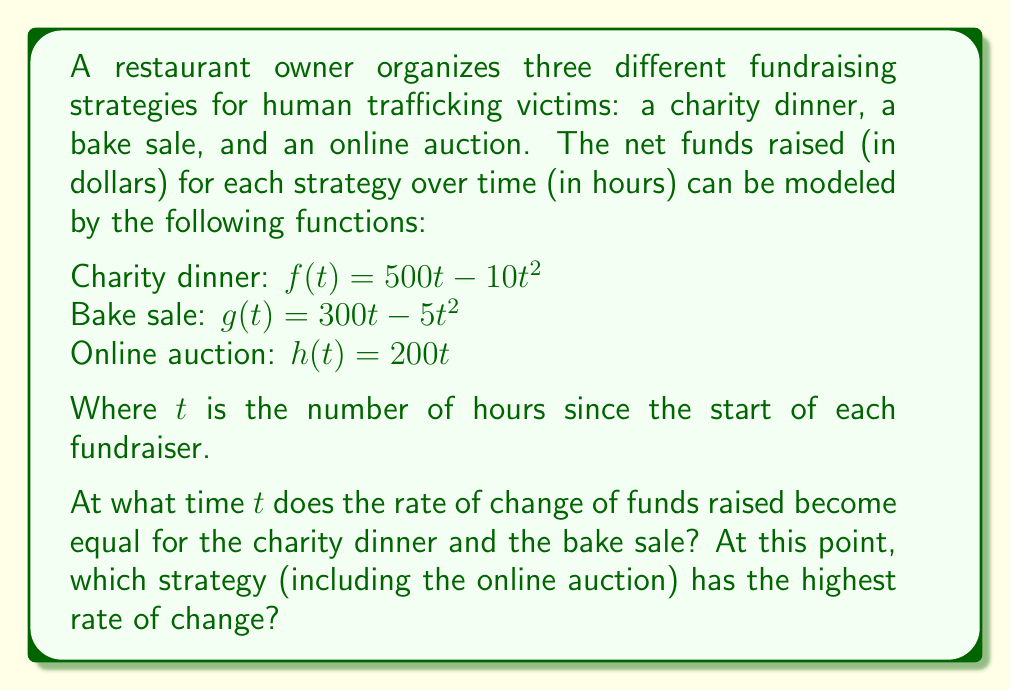Show me your answer to this math problem. To solve this problem, we need to follow these steps:

1) First, let's find the rate of change (derivative) for each fundraising strategy:

   Charity dinner: $f'(t) = 500 - 20t$
   Bake sale: $g'(t) = 300 - 10t$
   Online auction: $h'(t) = 200$

2) To find when the rate of change becomes equal for the charity dinner and bake sale, we set their derivatives equal to each other:

   $f'(t) = g'(t)$
   $500 - 20t = 300 - 10t$

3) Solve this equation:

   $500 - 20t = 300 - 10t$
   $200 = 10t$
   $t = 20$

4) At $t = 20$ hours, the rates of change for the charity dinner and bake sale are equal. Let's calculate this rate:

   $f'(20) = g'(20) = 500 - 20(20) = 300 - 10(20) = 100$ dollars per hour

5) Now, let's compare this to the rate of change of the online auction:

   $h'(t) = 200$ dollars per hour (constant)

6) At $t = 20$, the online auction has a higher rate of change (200 dollars/hour) compared to the other two strategies (100 dollars/hour).

Therefore, at $t = 20$ hours, the online auction has the highest rate of change among all three strategies.
Answer: $t = 20$ hours; Online auction 